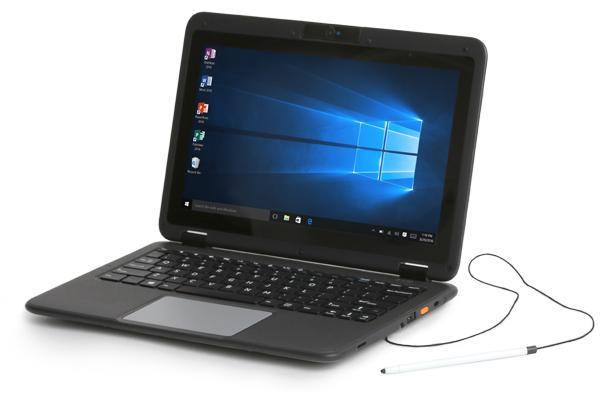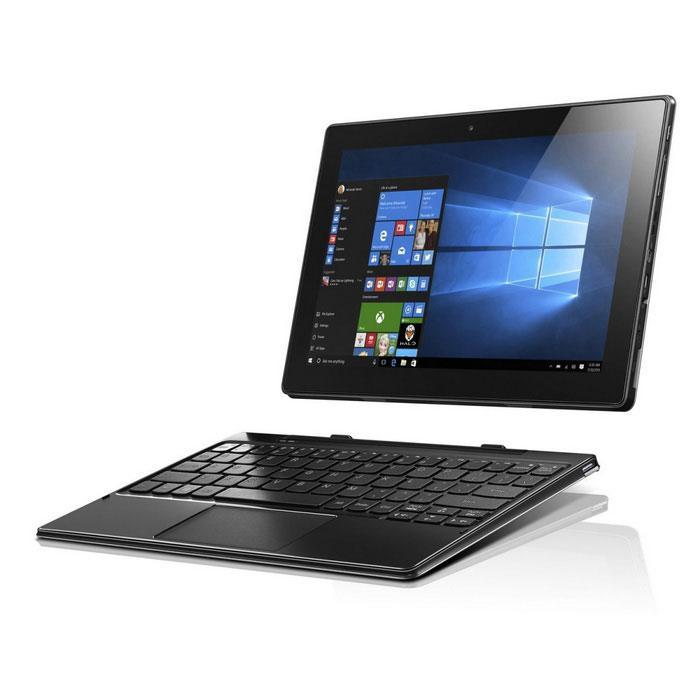The first image is the image on the left, the second image is the image on the right. Considering the images on both sides, is "All laptops have the screen part attached to the keyboard base, and no laptop is displayed head-on." valid? Answer yes or no. No. The first image is the image on the left, the second image is the image on the right. Analyze the images presented: Is the assertion "The computer in the image on the left has a black casing." valid? Answer yes or no. Yes. 